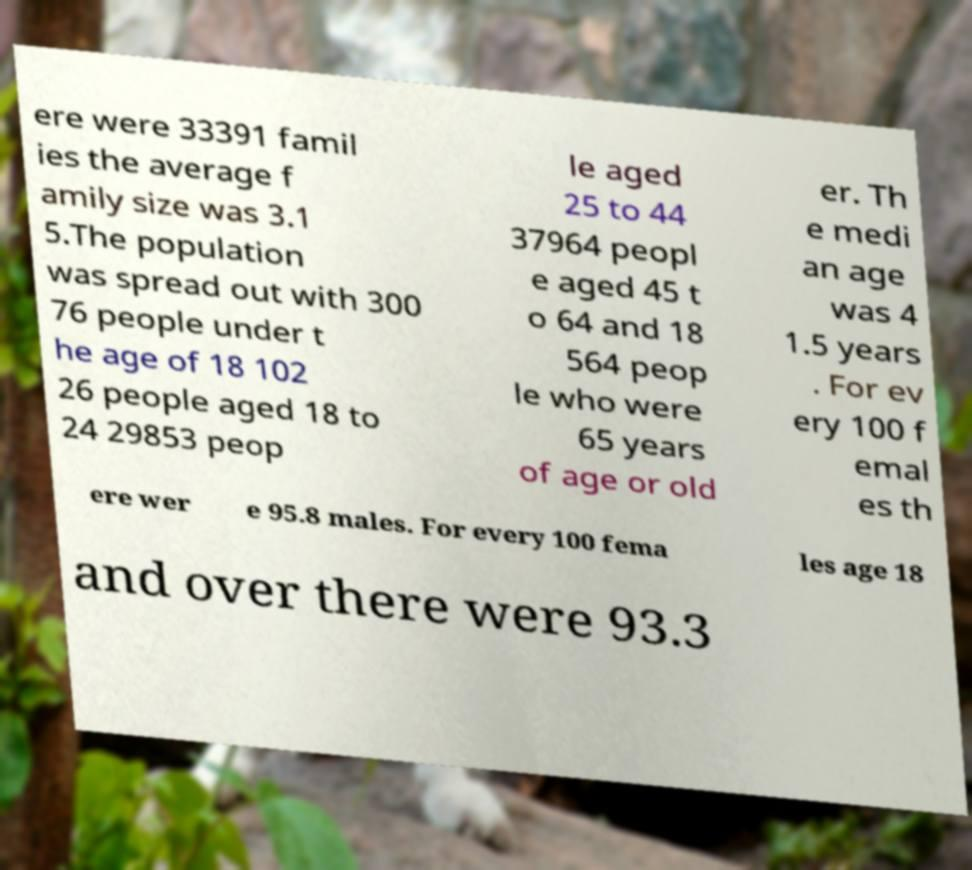For documentation purposes, I need the text within this image transcribed. Could you provide that? ere were 33391 famil ies the average f amily size was 3.1 5.The population was spread out with 300 76 people under t he age of 18 102 26 people aged 18 to 24 29853 peop le aged 25 to 44 37964 peopl e aged 45 t o 64 and 18 564 peop le who were 65 years of age or old er. Th e medi an age was 4 1.5 years . For ev ery 100 f emal es th ere wer e 95.8 males. For every 100 fema les age 18 and over there were 93.3 